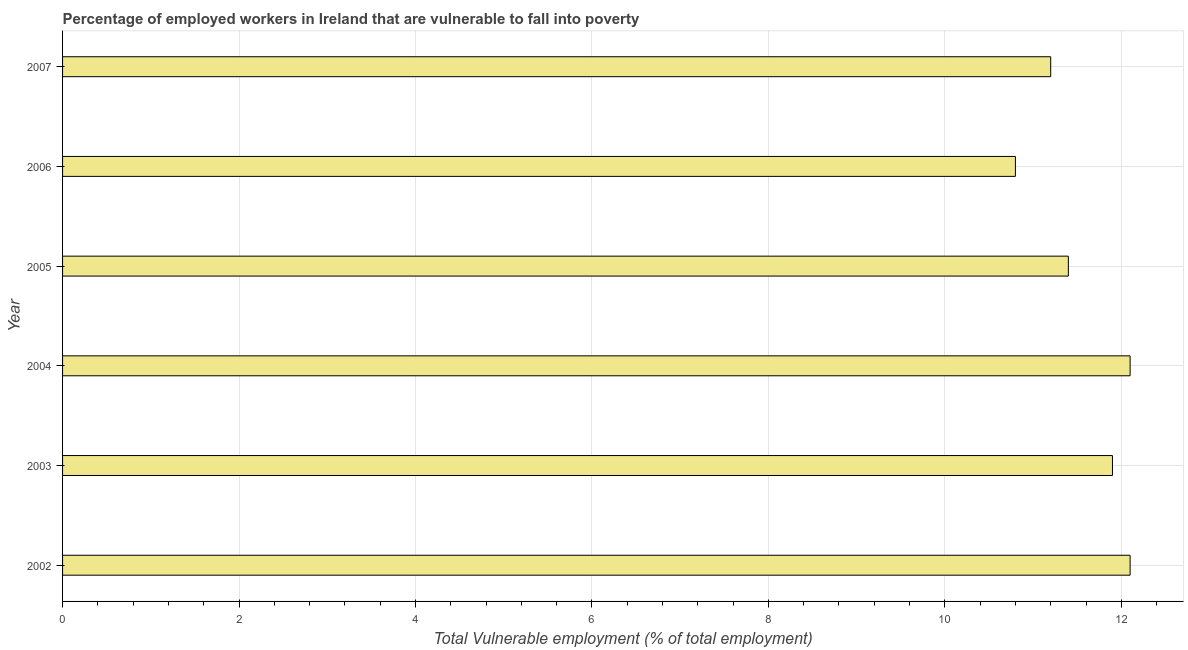Does the graph contain grids?
Provide a short and direct response. Yes. What is the title of the graph?
Your response must be concise. Percentage of employed workers in Ireland that are vulnerable to fall into poverty. What is the label or title of the X-axis?
Your response must be concise. Total Vulnerable employment (% of total employment). What is the total vulnerable employment in 2006?
Make the answer very short. 10.8. Across all years, what is the maximum total vulnerable employment?
Make the answer very short. 12.1. Across all years, what is the minimum total vulnerable employment?
Provide a succinct answer. 10.8. In which year was the total vulnerable employment maximum?
Your answer should be compact. 2002. In which year was the total vulnerable employment minimum?
Offer a terse response. 2006. What is the sum of the total vulnerable employment?
Offer a very short reply. 69.5. What is the difference between the total vulnerable employment in 2003 and 2006?
Keep it short and to the point. 1.1. What is the average total vulnerable employment per year?
Your answer should be compact. 11.58. What is the median total vulnerable employment?
Provide a succinct answer. 11.65. In how many years, is the total vulnerable employment greater than 4 %?
Provide a short and direct response. 6. Do a majority of the years between 2002 and 2006 (inclusive) have total vulnerable employment greater than 8 %?
Give a very brief answer. Yes. What is the ratio of the total vulnerable employment in 2003 to that in 2004?
Your answer should be compact. 0.98. Is the total vulnerable employment in 2005 less than that in 2006?
Your answer should be very brief. No. What is the difference between the highest and the second highest total vulnerable employment?
Ensure brevity in your answer.  0. Is the sum of the total vulnerable employment in 2004 and 2005 greater than the maximum total vulnerable employment across all years?
Offer a very short reply. Yes. Are all the bars in the graph horizontal?
Your answer should be compact. Yes. What is the difference between two consecutive major ticks on the X-axis?
Give a very brief answer. 2. Are the values on the major ticks of X-axis written in scientific E-notation?
Offer a very short reply. No. What is the Total Vulnerable employment (% of total employment) in 2002?
Offer a terse response. 12.1. What is the Total Vulnerable employment (% of total employment) in 2003?
Make the answer very short. 11.9. What is the Total Vulnerable employment (% of total employment) of 2004?
Give a very brief answer. 12.1. What is the Total Vulnerable employment (% of total employment) of 2005?
Keep it short and to the point. 11.4. What is the Total Vulnerable employment (% of total employment) of 2006?
Provide a short and direct response. 10.8. What is the Total Vulnerable employment (% of total employment) of 2007?
Your response must be concise. 11.2. What is the difference between the Total Vulnerable employment (% of total employment) in 2002 and 2004?
Make the answer very short. 0. What is the difference between the Total Vulnerable employment (% of total employment) in 2003 and 2004?
Your answer should be very brief. -0.2. What is the difference between the Total Vulnerable employment (% of total employment) in 2003 and 2005?
Ensure brevity in your answer.  0.5. What is the difference between the Total Vulnerable employment (% of total employment) in 2004 and 2007?
Keep it short and to the point. 0.9. What is the difference between the Total Vulnerable employment (% of total employment) in 2006 and 2007?
Your response must be concise. -0.4. What is the ratio of the Total Vulnerable employment (% of total employment) in 2002 to that in 2004?
Ensure brevity in your answer.  1. What is the ratio of the Total Vulnerable employment (% of total employment) in 2002 to that in 2005?
Make the answer very short. 1.06. What is the ratio of the Total Vulnerable employment (% of total employment) in 2002 to that in 2006?
Make the answer very short. 1.12. What is the ratio of the Total Vulnerable employment (% of total employment) in 2003 to that in 2005?
Offer a very short reply. 1.04. What is the ratio of the Total Vulnerable employment (% of total employment) in 2003 to that in 2006?
Provide a short and direct response. 1.1. What is the ratio of the Total Vulnerable employment (% of total employment) in 2003 to that in 2007?
Keep it short and to the point. 1.06. What is the ratio of the Total Vulnerable employment (% of total employment) in 2004 to that in 2005?
Ensure brevity in your answer.  1.06. What is the ratio of the Total Vulnerable employment (% of total employment) in 2004 to that in 2006?
Make the answer very short. 1.12. What is the ratio of the Total Vulnerable employment (% of total employment) in 2004 to that in 2007?
Provide a succinct answer. 1.08. What is the ratio of the Total Vulnerable employment (% of total employment) in 2005 to that in 2006?
Your response must be concise. 1.06. What is the ratio of the Total Vulnerable employment (% of total employment) in 2005 to that in 2007?
Provide a short and direct response. 1.02. 